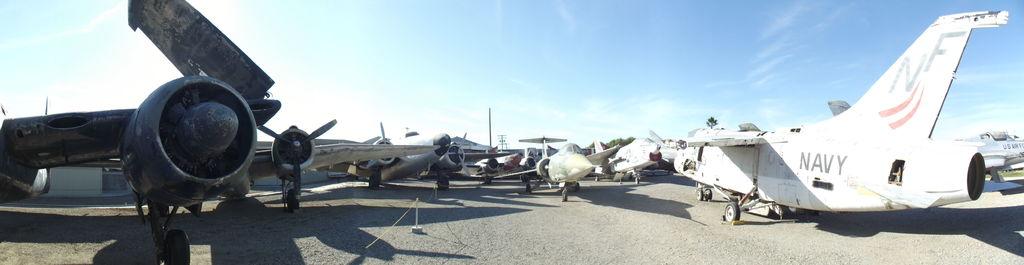What branch of the army is written on the plane on the right?
Keep it short and to the point. Navy. 